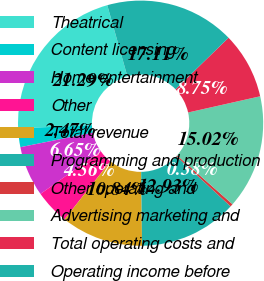Convert chart. <chart><loc_0><loc_0><loc_500><loc_500><pie_chart><fcel>Theatrical<fcel>Content licensing<fcel>Home entertainment<fcel>Other<fcel>Total revenue<fcel>Programming and production<fcel>Other operating and<fcel>Advertising marketing and<fcel>Total operating costs and<fcel>Operating income before<nl><fcel>21.29%<fcel>2.47%<fcel>6.65%<fcel>4.56%<fcel>10.84%<fcel>12.93%<fcel>0.38%<fcel>15.02%<fcel>8.75%<fcel>17.11%<nl></chart> 